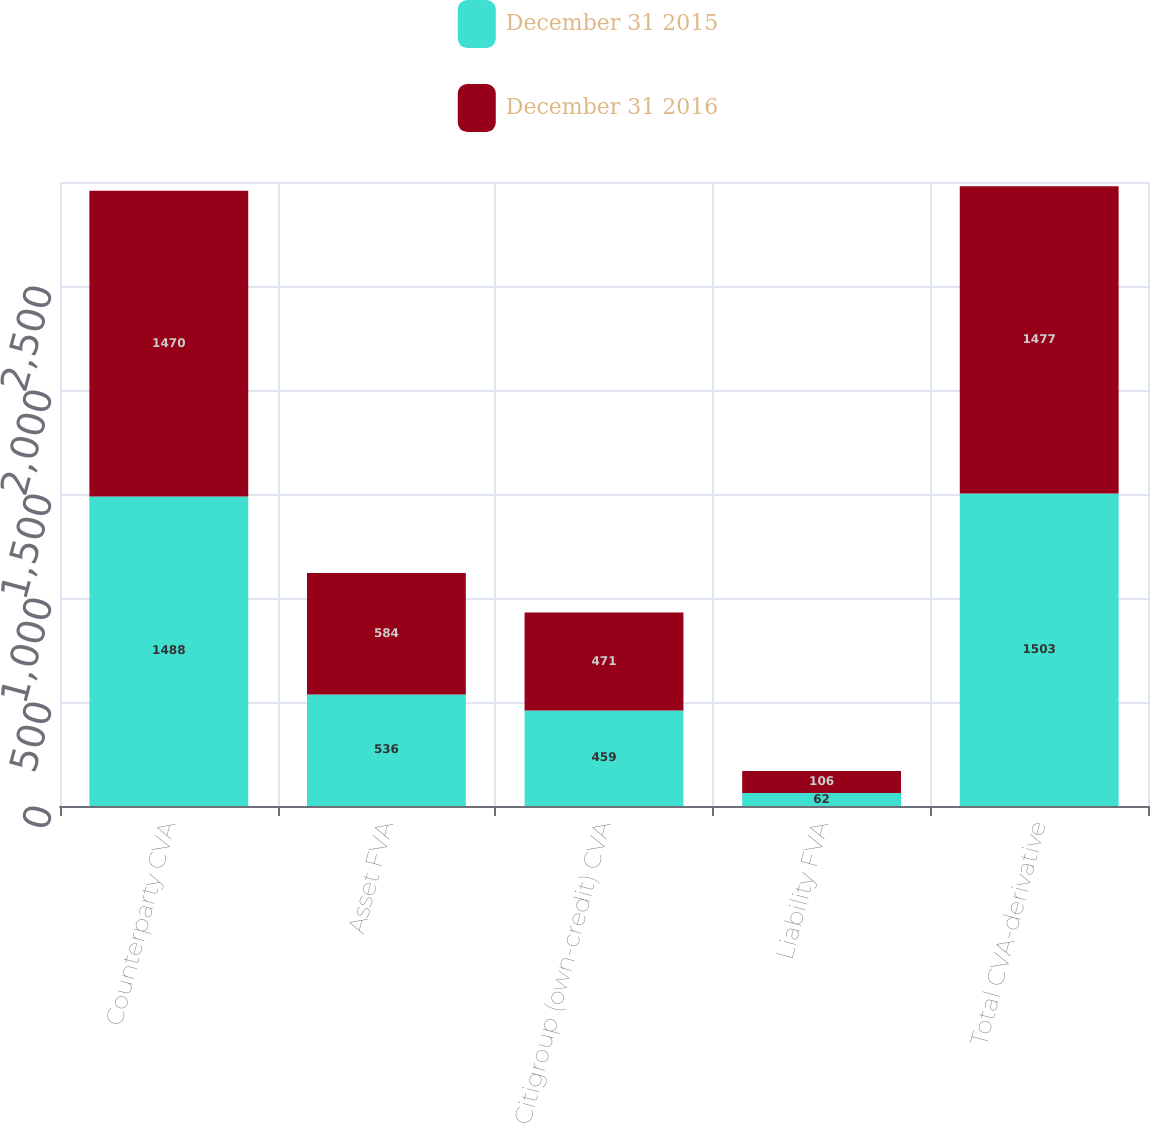Convert chart to OTSL. <chart><loc_0><loc_0><loc_500><loc_500><stacked_bar_chart><ecel><fcel>Counterparty CVA<fcel>Asset FVA<fcel>Citigroup (own-credit) CVA<fcel>Liability FVA<fcel>Total CVA-derivative<nl><fcel>December 31 2015<fcel>1488<fcel>536<fcel>459<fcel>62<fcel>1503<nl><fcel>December 31 2016<fcel>1470<fcel>584<fcel>471<fcel>106<fcel>1477<nl></chart> 